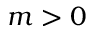<formula> <loc_0><loc_0><loc_500><loc_500>m > 0</formula> 